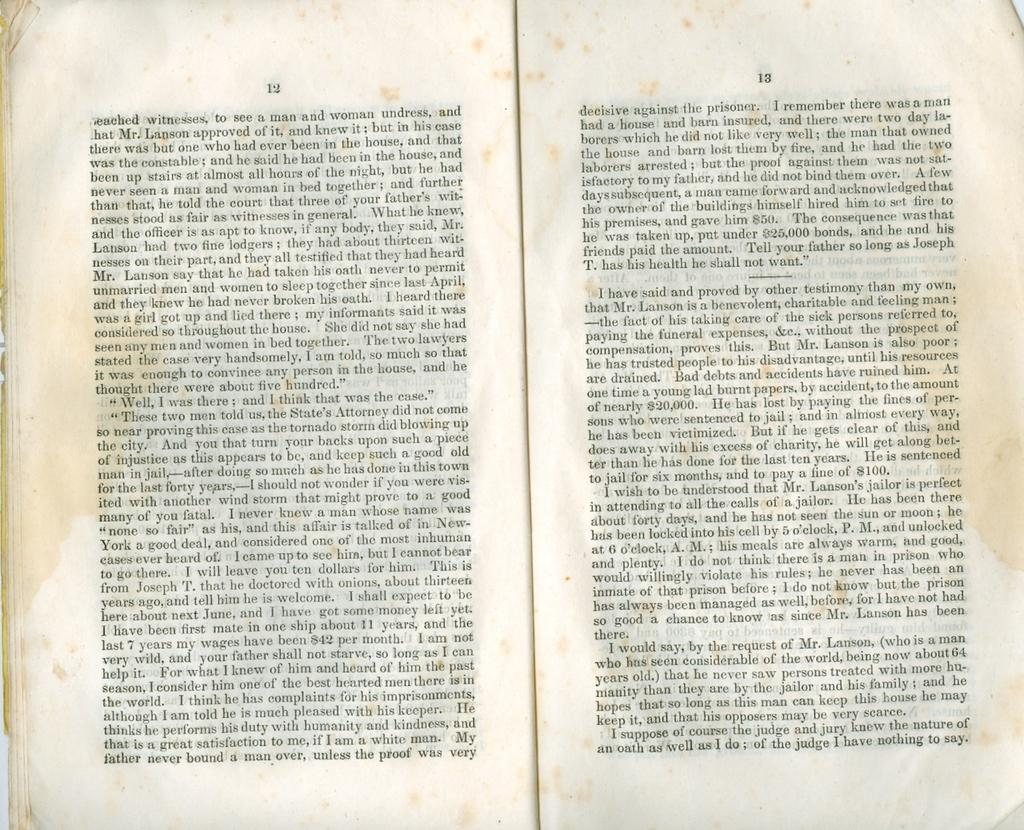<image>
Describe the image concisely. Open book with small letters on page 12 and 13. 